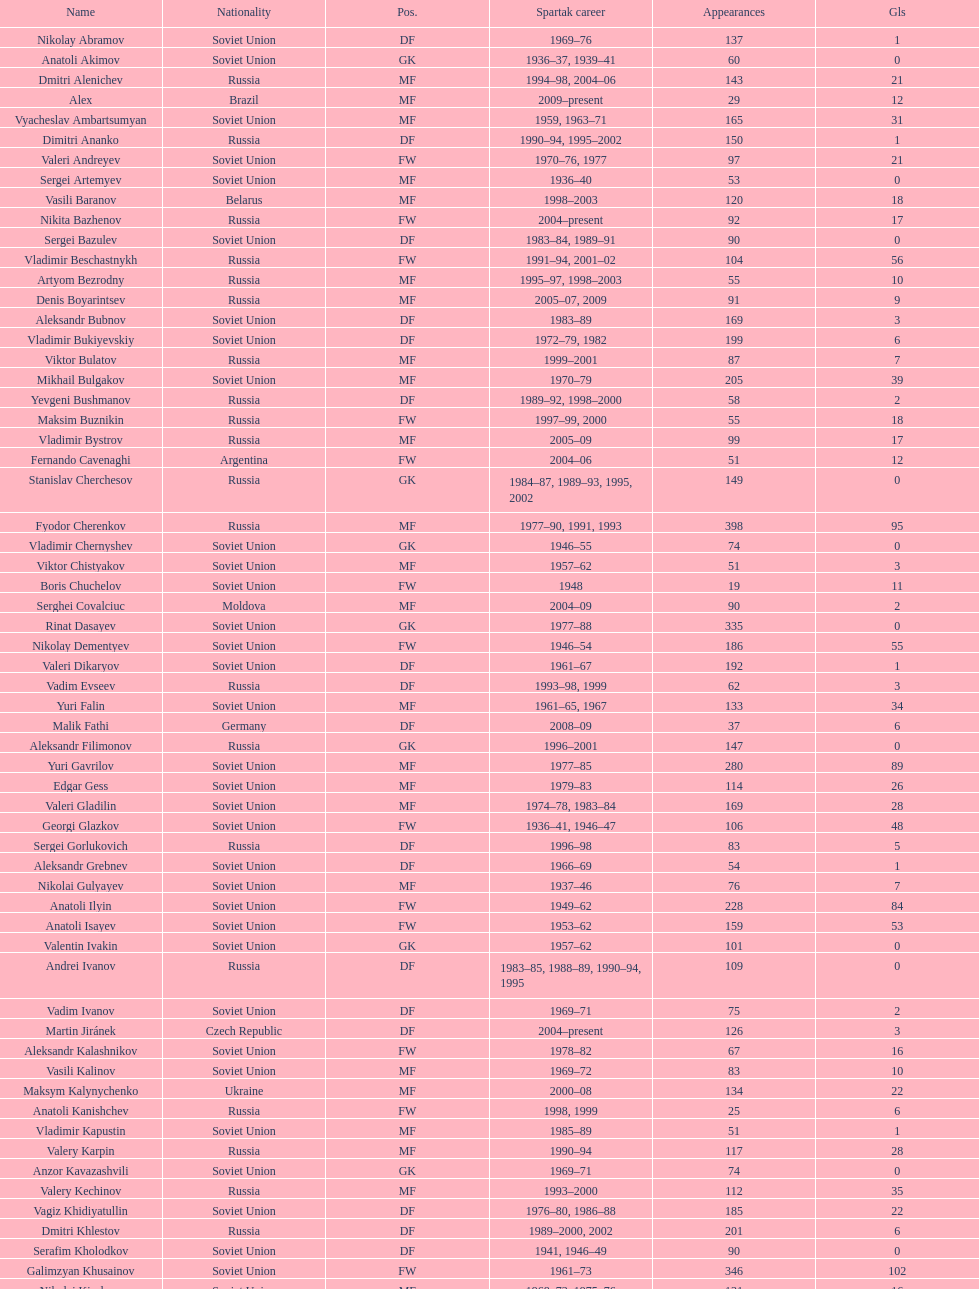Name two players with goals above 15. Dmitri Alenichev, Vyacheslav Ambartsumyan. 